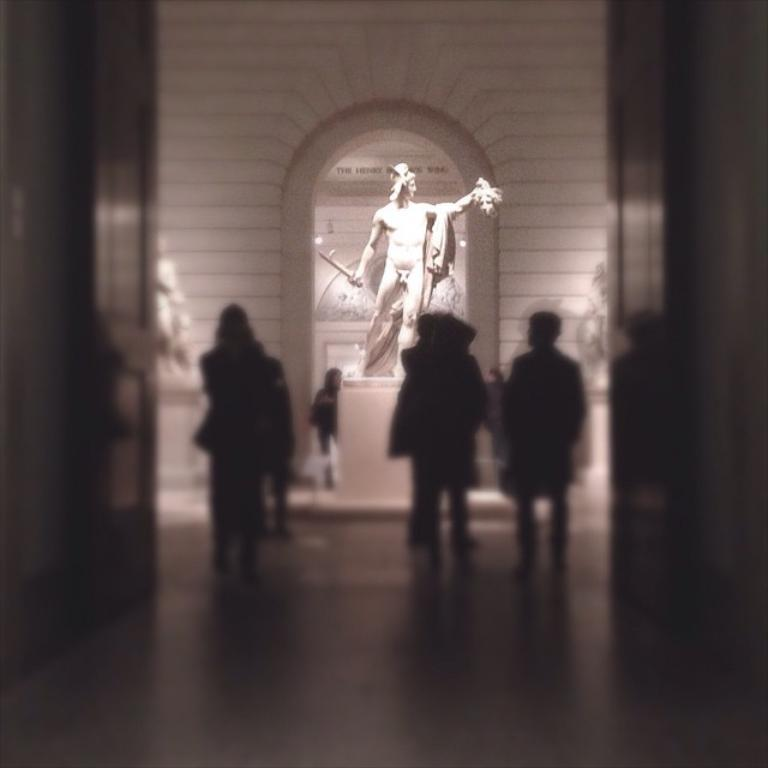What is happening in the image? There are people standing in the image. What can be observed about the floor in the image? The floor is blurred in the image. What is located in the background of the image? There is a statue in the background of the image. What is behind the statue in the background of the image? There is a wall behind the statue in the background of the image. What type of camera is being used by the people in the image? There is no camera visible in the image, and it is not mentioned that the people are using one. 